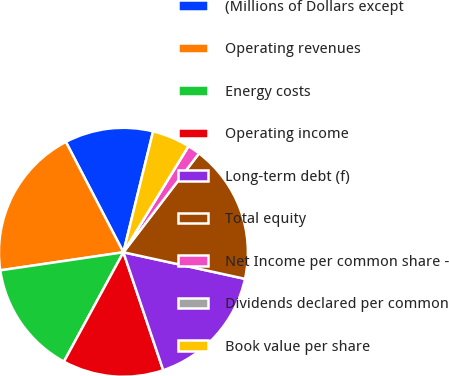<chart> <loc_0><loc_0><loc_500><loc_500><pie_chart><fcel>(Millions of Dollars except<fcel>Operating revenues<fcel>Energy costs<fcel>Operating income<fcel>Long-term debt (f)<fcel>Total equity<fcel>Net Income per common share -<fcel>Dividends declared per common<fcel>Book value per share<nl><fcel>11.48%<fcel>19.67%<fcel>14.75%<fcel>13.11%<fcel>16.39%<fcel>18.03%<fcel>1.64%<fcel>0.0%<fcel>4.92%<nl></chart> 